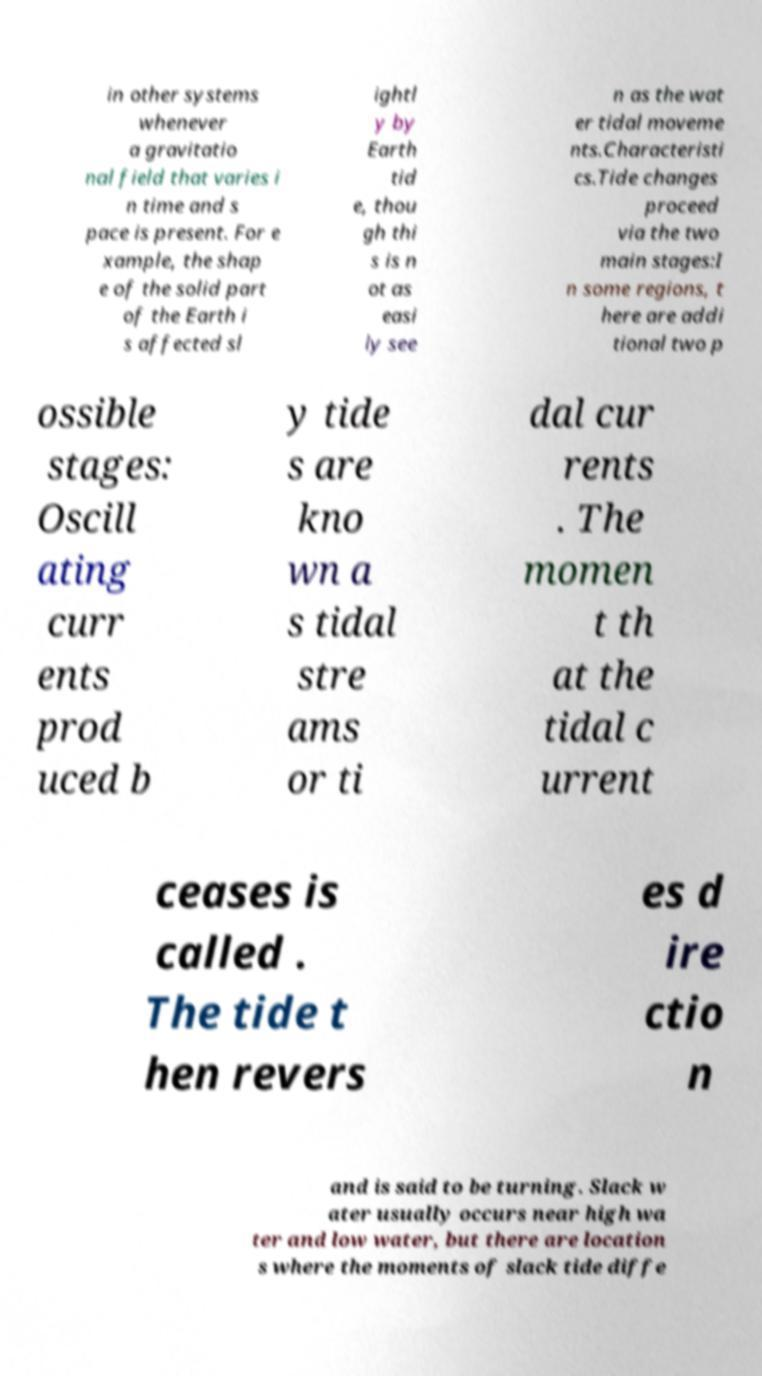Can you read and provide the text displayed in the image?This photo seems to have some interesting text. Can you extract and type it out for me? in other systems whenever a gravitatio nal field that varies i n time and s pace is present. For e xample, the shap e of the solid part of the Earth i s affected sl ightl y by Earth tid e, thou gh thi s is n ot as easi ly see n as the wat er tidal moveme nts.Characteristi cs.Tide changes proceed via the two main stages:I n some regions, t here are addi tional two p ossible stages: Oscill ating curr ents prod uced b y tide s are kno wn a s tidal stre ams or ti dal cur rents . The momen t th at the tidal c urrent ceases is called . The tide t hen revers es d ire ctio n and is said to be turning. Slack w ater usually occurs near high wa ter and low water, but there are location s where the moments of slack tide diffe 